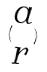Convert formula to latex. <formula><loc_0><loc_0><loc_500><loc_500>( \begin{matrix} a \\ r \end{matrix} )</formula> 